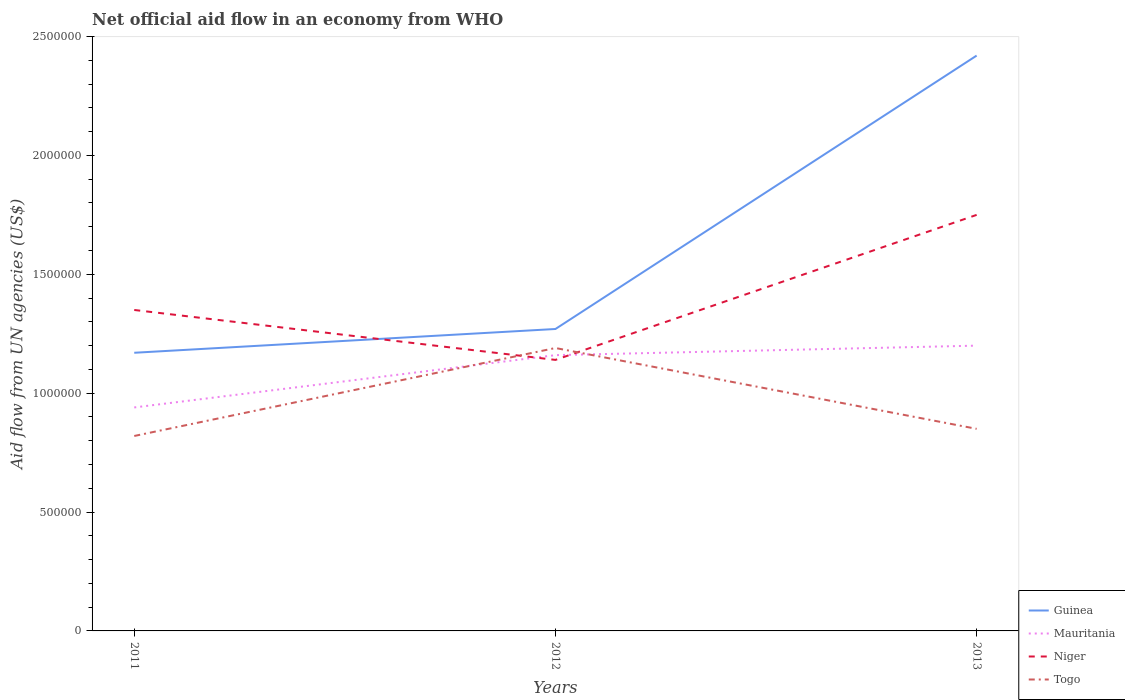How many different coloured lines are there?
Ensure brevity in your answer.  4. Does the line corresponding to Guinea intersect with the line corresponding to Niger?
Give a very brief answer. Yes. Across all years, what is the maximum net official aid flow in Mauritania?
Offer a terse response. 9.40e+05. What is the total net official aid flow in Guinea in the graph?
Keep it short and to the point. -1.15e+06. How many lines are there?
Keep it short and to the point. 4. What is the difference between two consecutive major ticks on the Y-axis?
Give a very brief answer. 5.00e+05. Are the values on the major ticks of Y-axis written in scientific E-notation?
Keep it short and to the point. No. Does the graph contain any zero values?
Provide a short and direct response. No. Does the graph contain grids?
Your answer should be compact. No. Where does the legend appear in the graph?
Your response must be concise. Bottom right. How are the legend labels stacked?
Keep it short and to the point. Vertical. What is the title of the graph?
Give a very brief answer. Net official aid flow in an economy from WHO. What is the label or title of the X-axis?
Your response must be concise. Years. What is the label or title of the Y-axis?
Give a very brief answer. Aid flow from UN agencies (US$). What is the Aid flow from UN agencies (US$) in Guinea in 2011?
Give a very brief answer. 1.17e+06. What is the Aid flow from UN agencies (US$) of Mauritania in 2011?
Make the answer very short. 9.40e+05. What is the Aid flow from UN agencies (US$) of Niger in 2011?
Your answer should be compact. 1.35e+06. What is the Aid flow from UN agencies (US$) of Togo in 2011?
Give a very brief answer. 8.20e+05. What is the Aid flow from UN agencies (US$) of Guinea in 2012?
Your answer should be compact. 1.27e+06. What is the Aid flow from UN agencies (US$) of Mauritania in 2012?
Give a very brief answer. 1.16e+06. What is the Aid flow from UN agencies (US$) of Niger in 2012?
Offer a terse response. 1.14e+06. What is the Aid flow from UN agencies (US$) in Togo in 2012?
Your answer should be compact. 1.19e+06. What is the Aid flow from UN agencies (US$) in Guinea in 2013?
Make the answer very short. 2.42e+06. What is the Aid flow from UN agencies (US$) of Mauritania in 2013?
Keep it short and to the point. 1.20e+06. What is the Aid flow from UN agencies (US$) of Niger in 2013?
Give a very brief answer. 1.75e+06. What is the Aid flow from UN agencies (US$) in Togo in 2013?
Keep it short and to the point. 8.50e+05. Across all years, what is the maximum Aid flow from UN agencies (US$) of Guinea?
Offer a terse response. 2.42e+06. Across all years, what is the maximum Aid flow from UN agencies (US$) in Mauritania?
Offer a terse response. 1.20e+06. Across all years, what is the maximum Aid flow from UN agencies (US$) in Niger?
Give a very brief answer. 1.75e+06. Across all years, what is the maximum Aid flow from UN agencies (US$) of Togo?
Give a very brief answer. 1.19e+06. Across all years, what is the minimum Aid flow from UN agencies (US$) in Guinea?
Ensure brevity in your answer.  1.17e+06. Across all years, what is the minimum Aid flow from UN agencies (US$) of Mauritania?
Offer a very short reply. 9.40e+05. Across all years, what is the minimum Aid flow from UN agencies (US$) of Niger?
Your answer should be very brief. 1.14e+06. Across all years, what is the minimum Aid flow from UN agencies (US$) of Togo?
Provide a succinct answer. 8.20e+05. What is the total Aid flow from UN agencies (US$) in Guinea in the graph?
Ensure brevity in your answer.  4.86e+06. What is the total Aid flow from UN agencies (US$) of Mauritania in the graph?
Provide a succinct answer. 3.30e+06. What is the total Aid flow from UN agencies (US$) of Niger in the graph?
Offer a very short reply. 4.24e+06. What is the total Aid flow from UN agencies (US$) in Togo in the graph?
Your answer should be very brief. 2.86e+06. What is the difference between the Aid flow from UN agencies (US$) of Guinea in 2011 and that in 2012?
Your answer should be compact. -1.00e+05. What is the difference between the Aid flow from UN agencies (US$) in Mauritania in 2011 and that in 2012?
Provide a short and direct response. -2.20e+05. What is the difference between the Aid flow from UN agencies (US$) of Niger in 2011 and that in 2012?
Provide a succinct answer. 2.10e+05. What is the difference between the Aid flow from UN agencies (US$) in Togo in 2011 and that in 2012?
Ensure brevity in your answer.  -3.70e+05. What is the difference between the Aid flow from UN agencies (US$) of Guinea in 2011 and that in 2013?
Keep it short and to the point. -1.25e+06. What is the difference between the Aid flow from UN agencies (US$) in Niger in 2011 and that in 2013?
Your response must be concise. -4.00e+05. What is the difference between the Aid flow from UN agencies (US$) of Togo in 2011 and that in 2013?
Provide a short and direct response. -3.00e+04. What is the difference between the Aid flow from UN agencies (US$) in Guinea in 2012 and that in 2013?
Offer a very short reply. -1.15e+06. What is the difference between the Aid flow from UN agencies (US$) of Niger in 2012 and that in 2013?
Offer a terse response. -6.10e+05. What is the difference between the Aid flow from UN agencies (US$) in Togo in 2012 and that in 2013?
Your answer should be very brief. 3.40e+05. What is the difference between the Aid flow from UN agencies (US$) in Guinea in 2011 and the Aid flow from UN agencies (US$) in Togo in 2012?
Make the answer very short. -2.00e+04. What is the difference between the Aid flow from UN agencies (US$) in Mauritania in 2011 and the Aid flow from UN agencies (US$) in Niger in 2012?
Provide a short and direct response. -2.00e+05. What is the difference between the Aid flow from UN agencies (US$) of Niger in 2011 and the Aid flow from UN agencies (US$) of Togo in 2012?
Offer a very short reply. 1.60e+05. What is the difference between the Aid flow from UN agencies (US$) in Guinea in 2011 and the Aid flow from UN agencies (US$) in Niger in 2013?
Keep it short and to the point. -5.80e+05. What is the difference between the Aid flow from UN agencies (US$) in Mauritania in 2011 and the Aid flow from UN agencies (US$) in Niger in 2013?
Ensure brevity in your answer.  -8.10e+05. What is the difference between the Aid flow from UN agencies (US$) in Niger in 2011 and the Aid flow from UN agencies (US$) in Togo in 2013?
Offer a very short reply. 5.00e+05. What is the difference between the Aid flow from UN agencies (US$) in Guinea in 2012 and the Aid flow from UN agencies (US$) in Niger in 2013?
Your response must be concise. -4.80e+05. What is the difference between the Aid flow from UN agencies (US$) in Mauritania in 2012 and the Aid flow from UN agencies (US$) in Niger in 2013?
Make the answer very short. -5.90e+05. What is the average Aid flow from UN agencies (US$) of Guinea per year?
Your answer should be very brief. 1.62e+06. What is the average Aid flow from UN agencies (US$) of Mauritania per year?
Your answer should be compact. 1.10e+06. What is the average Aid flow from UN agencies (US$) of Niger per year?
Your answer should be very brief. 1.41e+06. What is the average Aid flow from UN agencies (US$) of Togo per year?
Offer a terse response. 9.53e+05. In the year 2011, what is the difference between the Aid flow from UN agencies (US$) in Guinea and Aid flow from UN agencies (US$) in Mauritania?
Offer a terse response. 2.30e+05. In the year 2011, what is the difference between the Aid flow from UN agencies (US$) of Guinea and Aid flow from UN agencies (US$) of Niger?
Provide a succinct answer. -1.80e+05. In the year 2011, what is the difference between the Aid flow from UN agencies (US$) of Guinea and Aid flow from UN agencies (US$) of Togo?
Your answer should be very brief. 3.50e+05. In the year 2011, what is the difference between the Aid flow from UN agencies (US$) of Mauritania and Aid flow from UN agencies (US$) of Niger?
Your answer should be very brief. -4.10e+05. In the year 2011, what is the difference between the Aid flow from UN agencies (US$) in Mauritania and Aid flow from UN agencies (US$) in Togo?
Offer a terse response. 1.20e+05. In the year 2011, what is the difference between the Aid flow from UN agencies (US$) in Niger and Aid flow from UN agencies (US$) in Togo?
Provide a succinct answer. 5.30e+05. In the year 2012, what is the difference between the Aid flow from UN agencies (US$) in Guinea and Aid flow from UN agencies (US$) in Togo?
Your answer should be very brief. 8.00e+04. In the year 2012, what is the difference between the Aid flow from UN agencies (US$) of Mauritania and Aid flow from UN agencies (US$) of Niger?
Ensure brevity in your answer.  2.00e+04. In the year 2012, what is the difference between the Aid flow from UN agencies (US$) in Niger and Aid flow from UN agencies (US$) in Togo?
Your answer should be compact. -5.00e+04. In the year 2013, what is the difference between the Aid flow from UN agencies (US$) of Guinea and Aid flow from UN agencies (US$) of Mauritania?
Your response must be concise. 1.22e+06. In the year 2013, what is the difference between the Aid flow from UN agencies (US$) of Guinea and Aid flow from UN agencies (US$) of Niger?
Give a very brief answer. 6.70e+05. In the year 2013, what is the difference between the Aid flow from UN agencies (US$) in Guinea and Aid flow from UN agencies (US$) in Togo?
Your answer should be compact. 1.57e+06. In the year 2013, what is the difference between the Aid flow from UN agencies (US$) of Mauritania and Aid flow from UN agencies (US$) of Niger?
Offer a terse response. -5.50e+05. In the year 2013, what is the difference between the Aid flow from UN agencies (US$) in Mauritania and Aid flow from UN agencies (US$) in Togo?
Make the answer very short. 3.50e+05. In the year 2013, what is the difference between the Aid flow from UN agencies (US$) in Niger and Aid flow from UN agencies (US$) in Togo?
Provide a short and direct response. 9.00e+05. What is the ratio of the Aid flow from UN agencies (US$) of Guinea in 2011 to that in 2012?
Offer a terse response. 0.92. What is the ratio of the Aid flow from UN agencies (US$) of Mauritania in 2011 to that in 2012?
Your answer should be very brief. 0.81. What is the ratio of the Aid flow from UN agencies (US$) in Niger in 2011 to that in 2012?
Offer a terse response. 1.18. What is the ratio of the Aid flow from UN agencies (US$) in Togo in 2011 to that in 2012?
Your answer should be very brief. 0.69. What is the ratio of the Aid flow from UN agencies (US$) in Guinea in 2011 to that in 2013?
Offer a terse response. 0.48. What is the ratio of the Aid flow from UN agencies (US$) of Mauritania in 2011 to that in 2013?
Offer a terse response. 0.78. What is the ratio of the Aid flow from UN agencies (US$) in Niger in 2011 to that in 2013?
Offer a terse response. 0.77. What is the ratio of the Aid flow from UN agencies (US$) in Togo in 2011 to that in 2013?
Make the answer very short. 0.96. What is the ratio of the Aid flow from UN agencies (US$) in Guinea in 2012 to that in 2013?
Your answer should be very brief. 0.52. What is the ratio of the Aid flow from UN agencies (US$) in Mauritania in 2012 to that in 2013?
Your answer should be compact. 0.97. What is the ratio of the Aid flow from UN agencies (US$) in Niger in 2012 to that in 2013?
Keep it short and to the point. 0.65. What is the ratio of the Aid flow from UN agencies (US$) of Togo in 2012 to that in 2013?
Offer a very short reply. 1.4. What is the difference between the highest and the second highest Aid flow from UN agencies (US$) of Guinea?
Your answer should be compact. 1.15e+06. What is the difference between the highest and the second highest Aid flow from UN agencies (US$) of Niger?
Provide a succinct answer. 4.00e+05. What is the difference between the highest and the second highest Aid flow from UN agencies (US$) in Togo?
Make the answer very short. 3.40e+05. What is the difference between the highest and the lowest Aid flow from UN agencies (US$) in Guinea?
Make the answer very short. 1.25e+06. What is the difference between the highest and the lowest Aid flow from UN agencies (US$) of Togo?
Provide a succinct answer. 3.70e+05. 